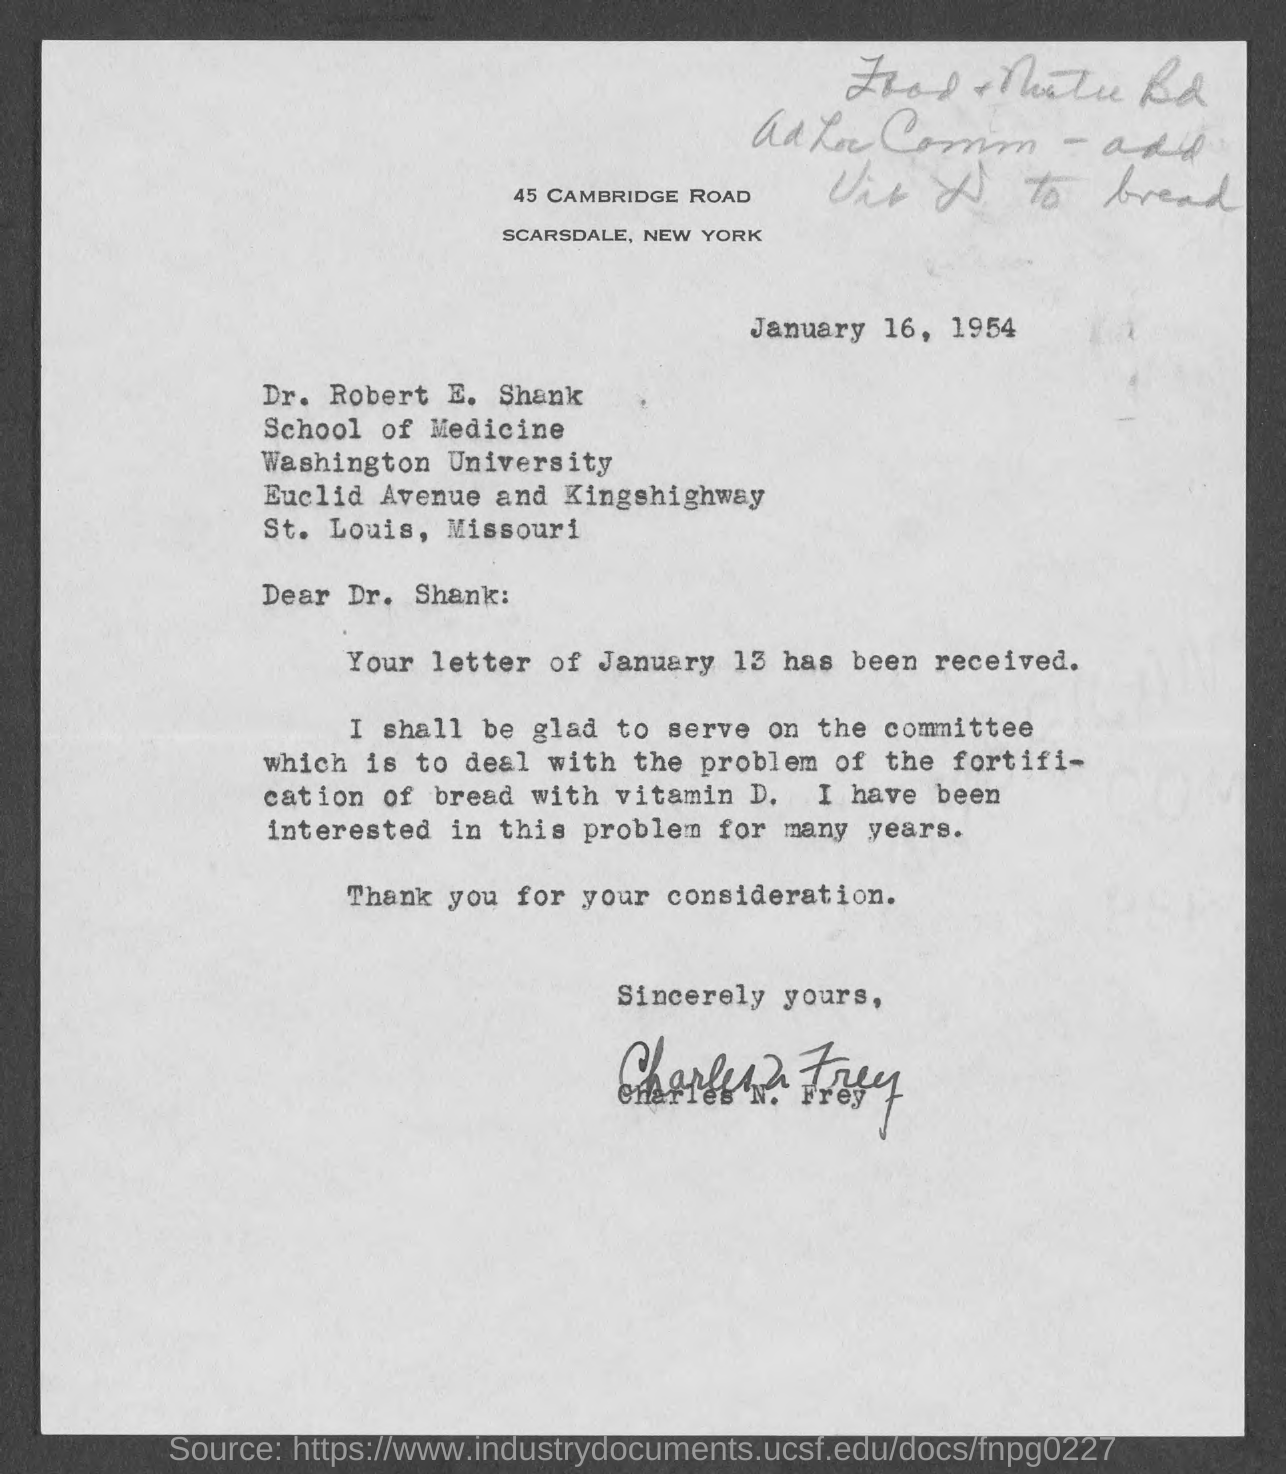Give some essential details in this illustration. The date is January 16, 1954. The salutation of the letter is "Dear Dr. Shank:... 